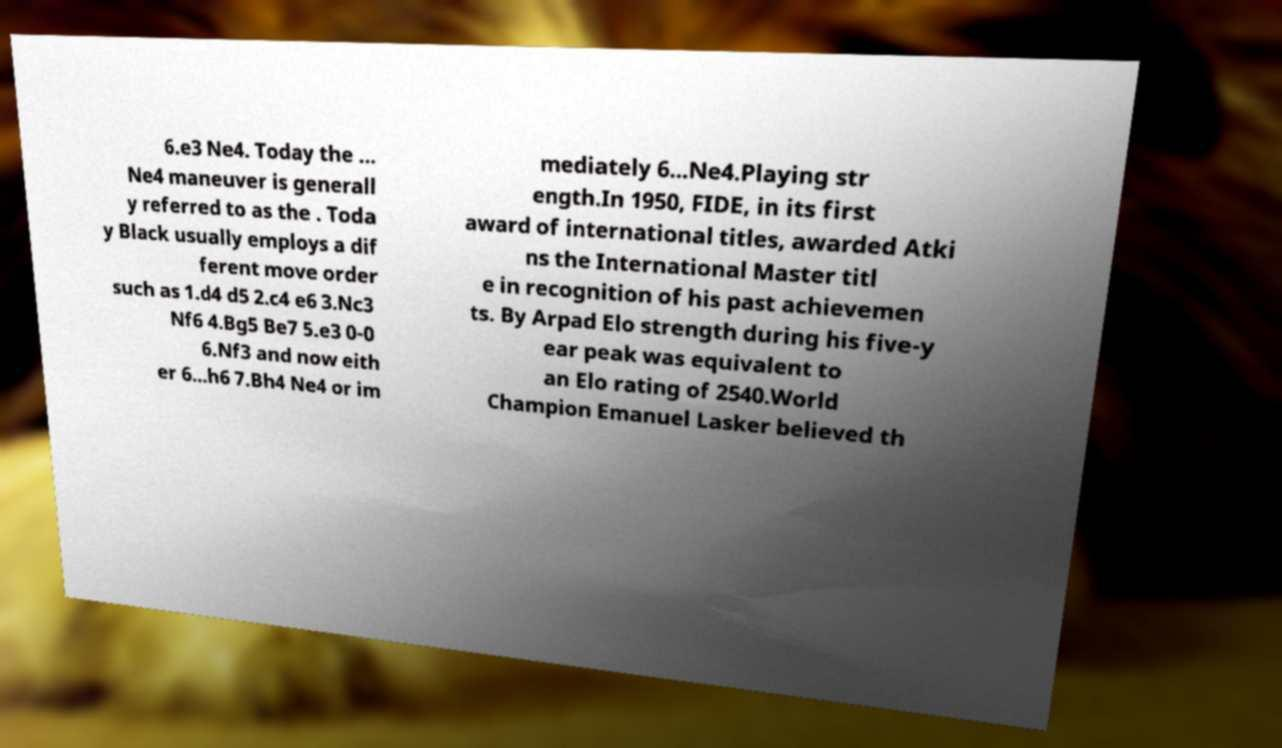Could you extract and type out the text from this image? 6.e3 Ne4. Today the ... Ne4 maneuver is generall y referred to as the . Toda y Black usually employs a dif ferent move order such as 1.d4 d5 2.c4 e6 3.Nc3 Nf6 4.Bg5 Be7 5.e3 0-0 6.Nf3 and now eith er 6...h6 7.Bh4 Ne4 or im mediately 6...Ne4.Playing str ength.In 1950, FIDE, in its first award of international titles, awarded Atki ns the International Master titl e in recognition of his past achievemen ts. By Arpad Elo strength during his five-y ear peak was equivalent to an Elo rating of 2540.World Champion Emanuel Lasker believed th 